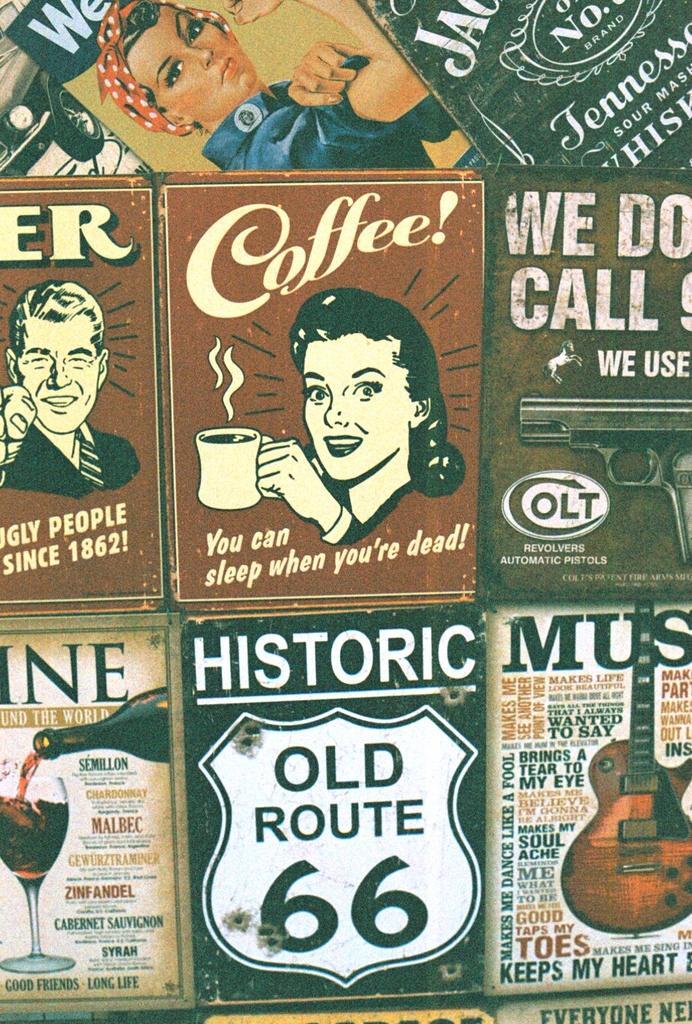How would you summarize this image in a sentence or two? Here we can see posts,on these posters we can see people,guitar,glass with drink and bottle. 